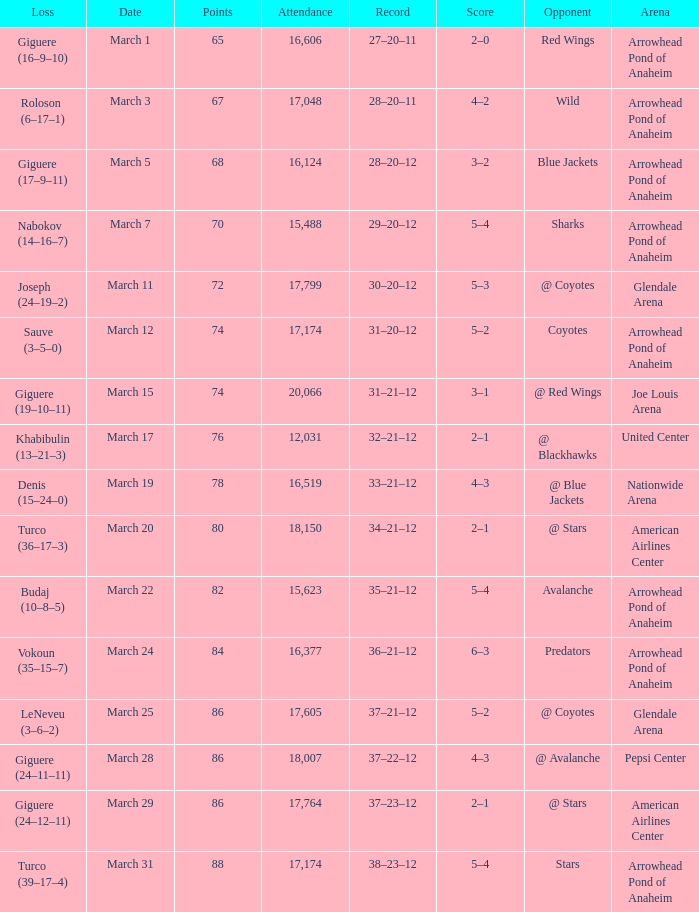What is the Score of the game on March 19? 4–3. 